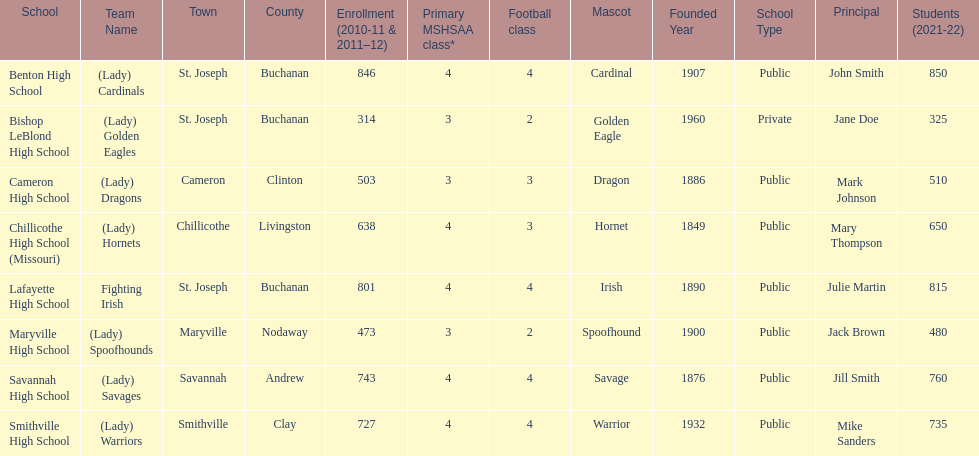Benton high school and bishop leblond high school are both located in what town? St. Joseph. 